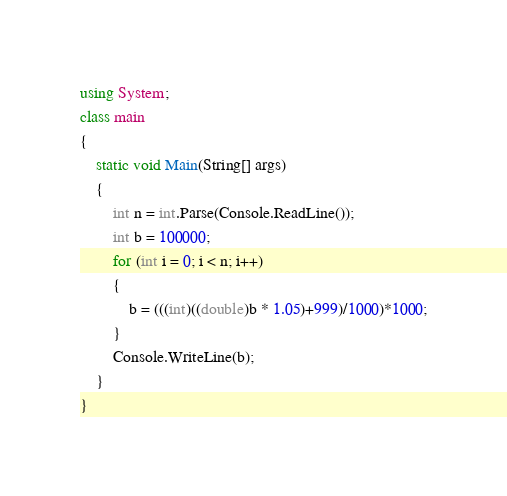Convert code to text. <code><loc_0><loc_0><loc_500><loc_500><_C#_>using System;
class main
{
    static void Main(String[] args)
    {
        int n = int.Parse(Console.ReadLine());
        int b = 100000;
        for (int i = 0; i < n; i++)
        {
            b = (((int)((double)b * 1.05)+999)/1000)*1000;
        }
        Console.WriteLine(b);
    }
}</code> 